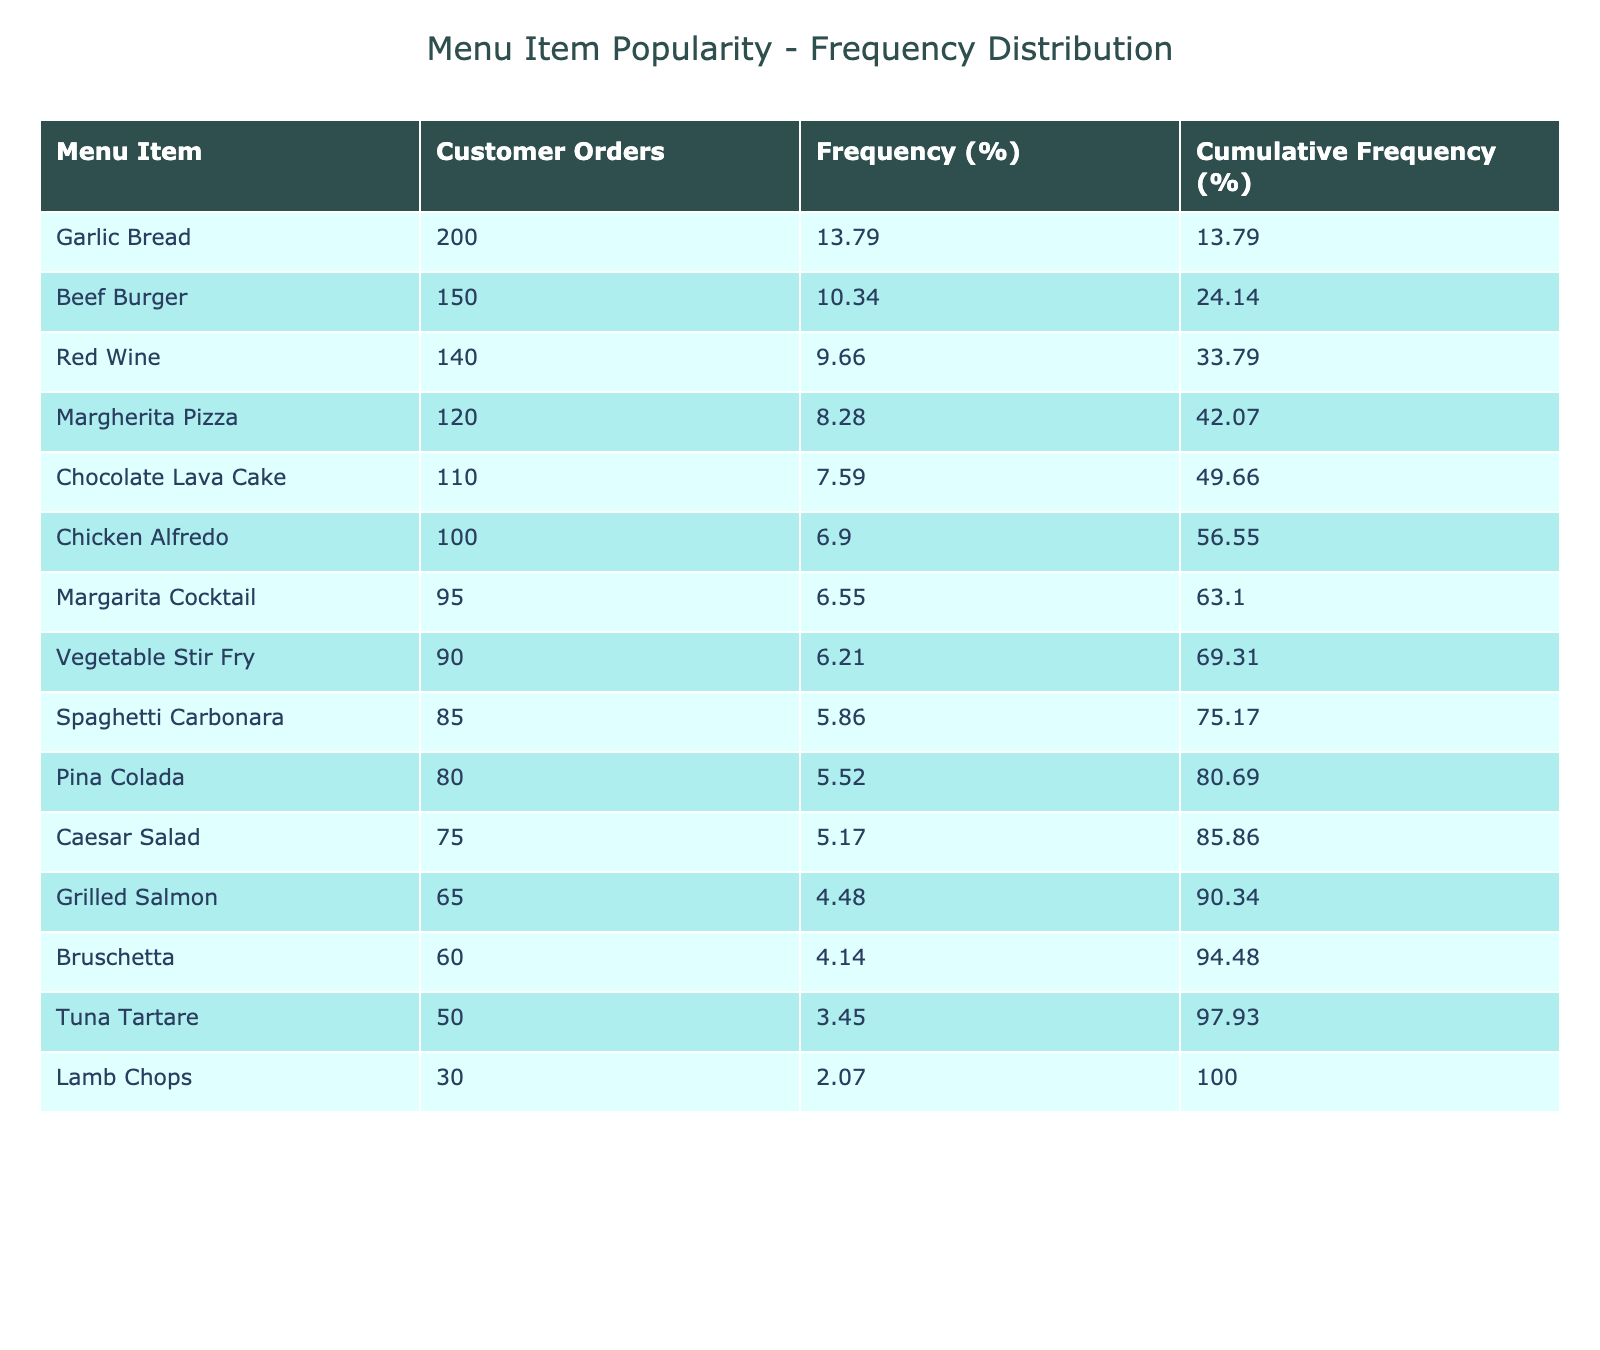What is the total number of customer orders for all menu items? To find the total customer orders, sum the values in the 'Customer Orders' column: 120 + 85 + 75 + 100 + 150 + 65 + 90 + 50 + 30 + 110 + 95 + 140 + 80 + 200 + 60 = 1,310.
Answer: 1310 Which menu item has the highest number of customer orders? By examining the 'Customer Orders' column, I can see that the highest value is 200 for 'Garlic Bread'.
Answer: Garlic Bread What percentage of total orders did the Chicken Alfredo receive? First, determine the total orders (1,310). Then, calculate the percentage for Chicken Alfredo: (100 / 1310) * 100 = 7.63.
Answer: 7.63 Is the Culinary Delight item included in the table? There is no mention of a 'Culinary Delight' item in the table, suggesting that it is not part of the offerings.
Answer: No What is the cumulative percentage of customer orders for the top three items? The top three items with the highest orders are Garlic Bread (200), Beef Burger (150), and Red Wine (140). Their individual percentages are: Garlic Bread (15.27), Beef Burger (11.45), and Red Wine (10.67). The cumulative percentage is calculated by adding these three values: 15.27 + 11.45 + 10.67 = 37.39.
Answer: 37.39 How many items received more than 100 customer orders? Count the menu items with orders greater than 100: Garlic Bread (200), Beef Burger (150), Red Wine (140), Margherita Pizza (120), and Chocolate Lava Cake (110). This totals up to 5 items.
Answer: 5 Which item has a frequency percentage closest to 10%? First, calculate the frequency percentage for all items. The 'Red Wine' has approximately 10.67%, which is the closest percentage to 10%.
Answer: Red Wine What is the average number of customer orders for all items listed? The average is calculated by dividing the total orders (1,310) by the number of items (15): 1310 / 15 = 87.33.
Answer: 87.33 Which menu items fall into the category of low popularity, defined as orders below the average? The average number of orders is 87.33. The items below this average are: Caesar Salad (75), Grilled Salmon (65), Tuna Tartare (50), Lamb Chops (30), and Bruschetta (60), totaling 5 items.
Answer: 5 items 